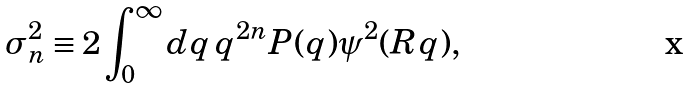Convert formula to latex. <formula><loc_0><loc_0><loc_500><loc_500>\sigma _ { n } ^ { 2 } \equiv 2 \int _ { 0 } ^ { \infty } d q \, q ^ { 2 n } P ( q ) \psi ^ { 2 } ( R q ) ,</formula> 